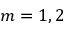<formula> <loc_0><loc_0><loc_500><loc_500>m = 1 , 2</formula> 